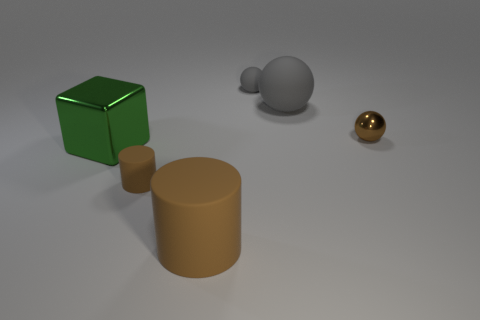Subtract all green cubes. How many gray balls are left? 2 Subtract all small balls. How many balls are left? 1 Add 2 large green matte blocks. How many objects exist? 8 Subtract all cubes. How many objects are left? 5 Subtract all big green matte balls. Subtract all tiny metal things. How many objects are left? 5 Add 4 tiny gray rubber balls. How many tiny gray rubber balls are left? 5 Add 5 big green metallic objects. How many big green metallic objects exist? 6 Subtract 0 green cylinders. How many objects are left? 6 